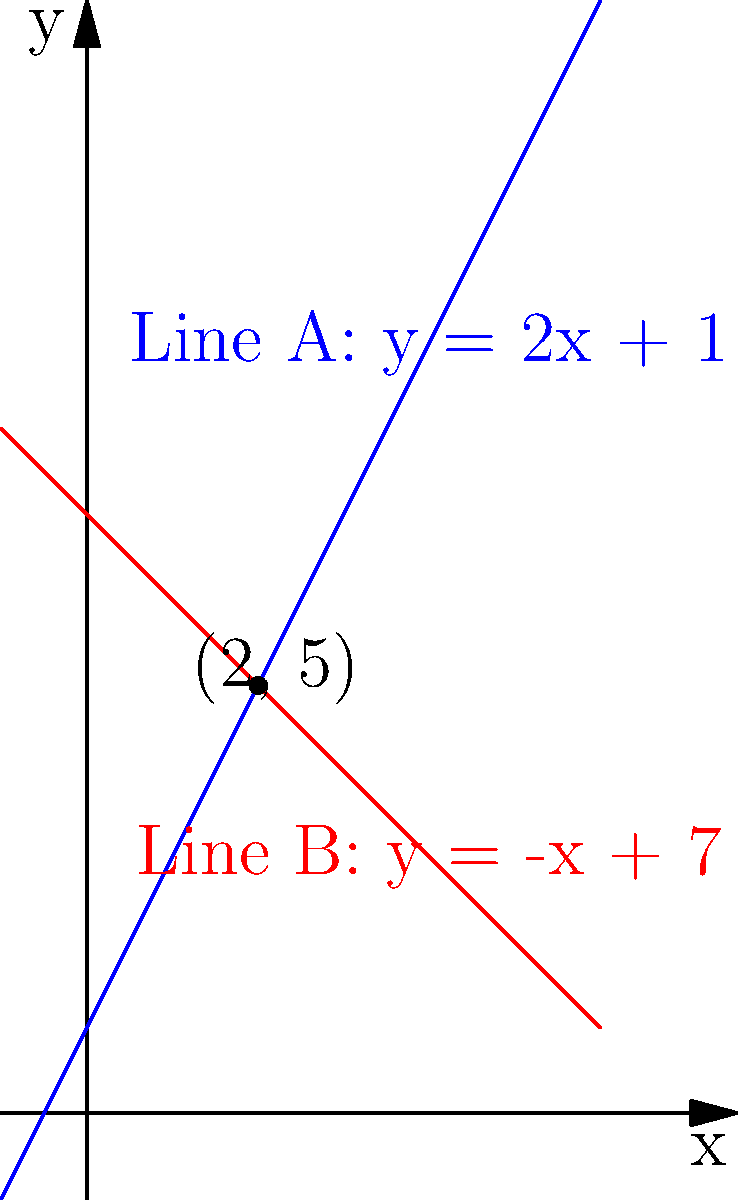Two production lines in your factory are represented by the following equations:

Line A: $y = 2x + 1$
Line B: $y = -x + 7$

Where $x$ represents the number of hours worked, and $y$ represents the number of units produced. At what point do these production lines intersect, and what does this intersection represent in terms of production efficiency? To find the intersection point of the two production lines, we need to solve the system of equations:

1) $y = 2x + 1$ (Line A)
2) $y = -x + 7$ (Line B)

At the intersection point, the $y$ values are equal, so we can set the right sides of the equations equal to each other:

3) $2x + 1 = -x + 7$

Now, let's solve for $x$:

4) $2x + x = 7 - 1$
5) $3x = 6$
6) $x = 2$

To find the $y$ coordinate, we can substitute $x = 2$ into either of the original equations. Let's use Line A:

7) $y = 2(2) + 1 = 4 + 1 = 5$

Therefore, the intersection point is $(2, 5)$.

This point represents:
- After 2 hours of work (x-coordinate)
- Both production lines will have produced 5 units (y-coordinate)

In terms of production efficiency, this intersection point indicates that after 2 hours, both production lines are equally efficient, having produced 5 units each. Before this point, Line B is more efficient (produces more units per hour), while after this point, Line A becomes more efficient.
Answer: $(2, 5)$; After 2 hours, both lines produce 5 units, with Line B more efficient before and Line A more efficient after. 